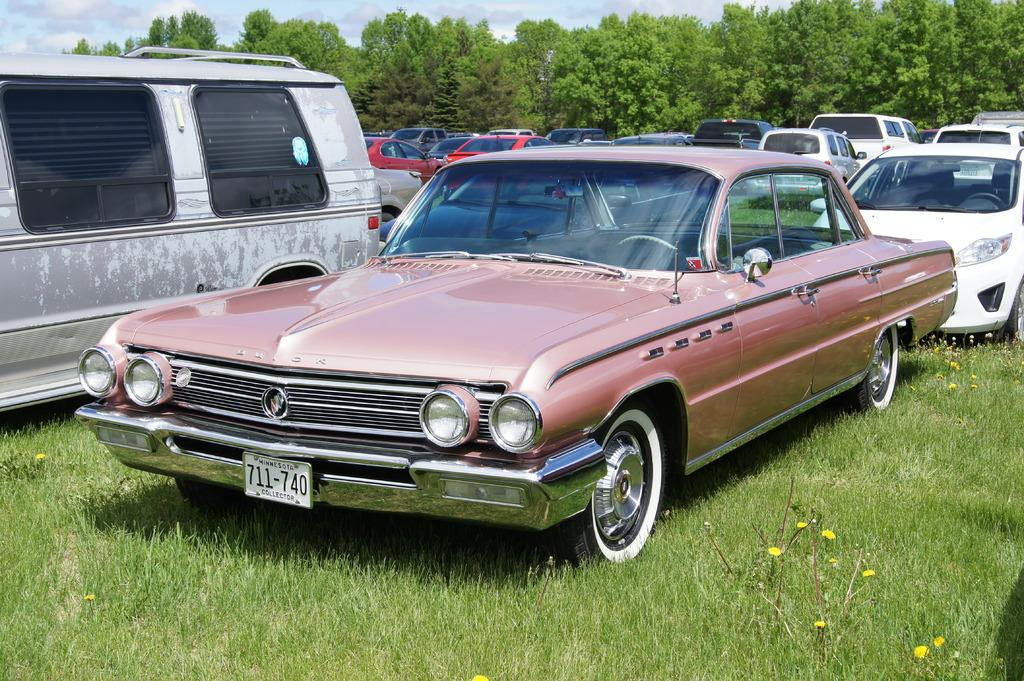What can be seen in large numbers in the image? There are many vehicles in the image. What type of vegetation is present on the ground in the image? There is grass and flowers on the ground in the image. What can be seen in the background of the image? There are trees and the sky visible in the background of the image. Where is the notebook located in the image? There is no notebook present in the image. What type of nut can be seen growing on the trees in the image? There are no nuts visible in the image, as it only shows trees in the background. 